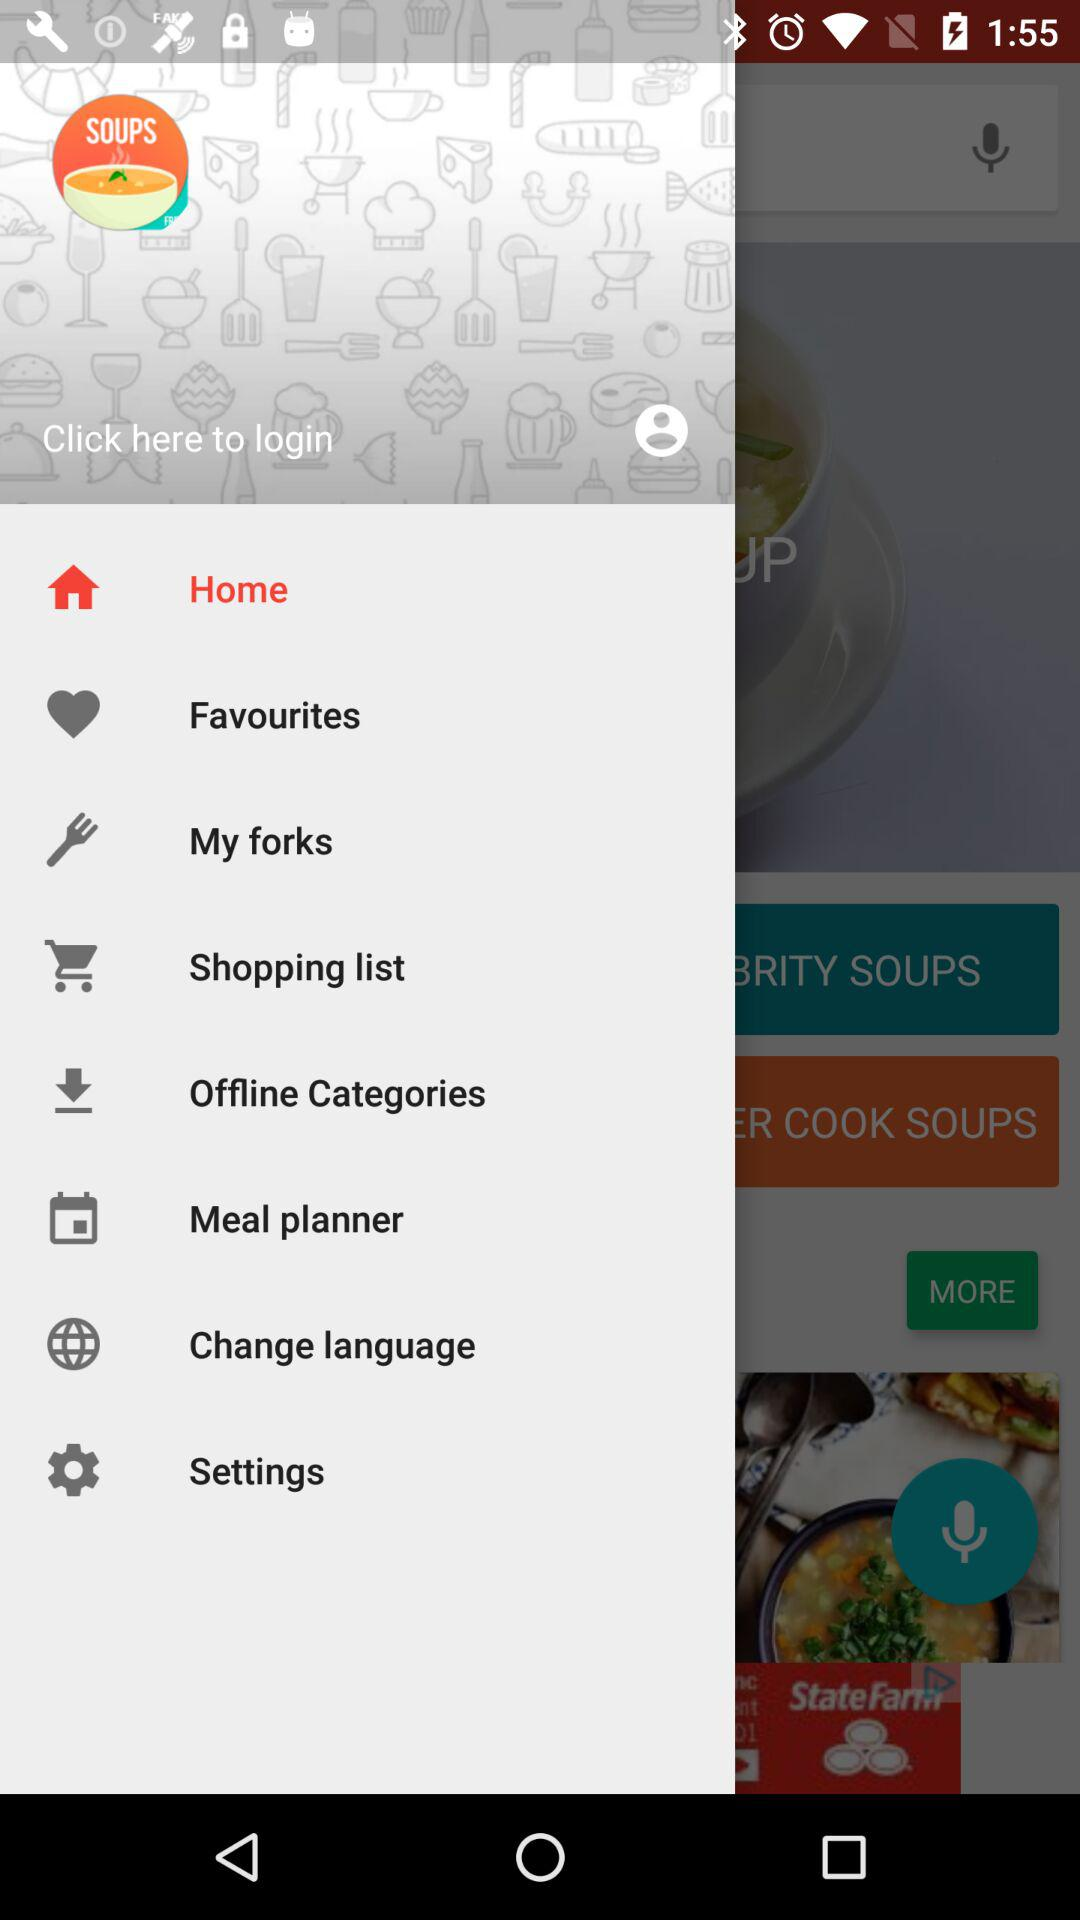How many items are in "My forks"?
When the provided information is insufficient, respond with <no answer>. <no answer> 